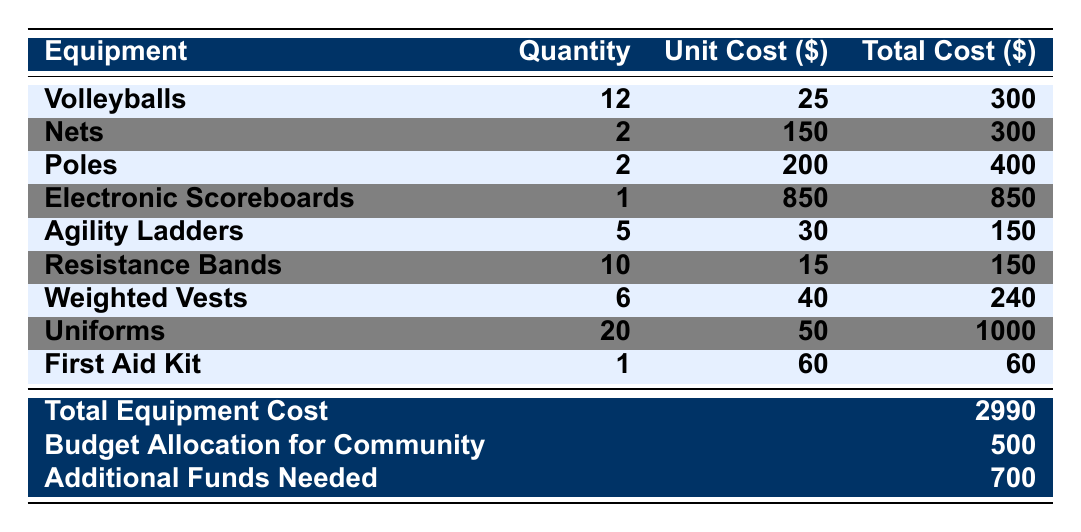What is the total cost for volleyballs? The total cost for volleyballs is provided in the table. It lists a total cost of \$300.
Answer: 300 How many nets were purchased? The quantity of nets is indicated in the table as 2.
Answer: 2 What is the unit cost of a pole? The unit cost for poles is directly listed in the table as \$200.
Answer: 200 What is the total cost of training equipment? The total training cost is stated as \$540 in the training equipment section of the table.
Answer: 540 What is the total allocated cost for the volleyball program? The table presents a total equipment cost of \$2990, which is the overall allocated budget for the volleyball program.
Answer: 2990 Did the budget allocation cover all equipment costs? The budget allocation of \$500 does not cover the total equipment cost of \$2990; therefore, the answer is no.
Answer: No How much additional funding is needed? The additional funds needed are explicitly listed in the table as \$700.
Answer: 700 If we sum the total costs of volleyballs, nets, and poles, what do we get? The total costs are \$300 (volleyballs) + \$300 (nets) + \$400 (poles) = \$1000.
Answer: 1000 What percentage of the total equipment cost does the cost of uniforms represent? The cost of uniforms is \$1000 out of a total equipment cost of \$2990. The percentage is (1000/2990)*100 ≈ 33.44%.
Answer: 33.44% What will be the total shortfall if the additional funds were not covered? The shortfall can be calculated by combining total equipment costs and subtracting the budget allocation. The calculation is \$2990 - \$500 = \$2490. Thus, if only the budget is considered, the total shortfall is \$2490.
Answer: 2490 